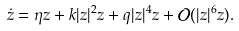Convert formula to latex. <formula><loc_0><loc_0><loc_500><loc_500>\dot { z } = \eta z + k | z | ^ { 2 } z + q | z | ^ { 4 } z + \mathcal { O } ( | z | ^ { 6 } z ) .</formula> 